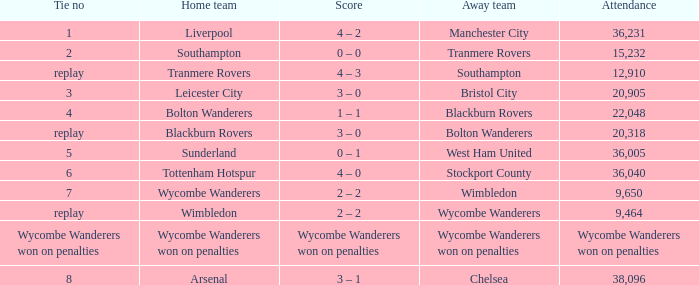Which away team had a draw with a score of 2 and what was their name? Tranmere Rovers. 